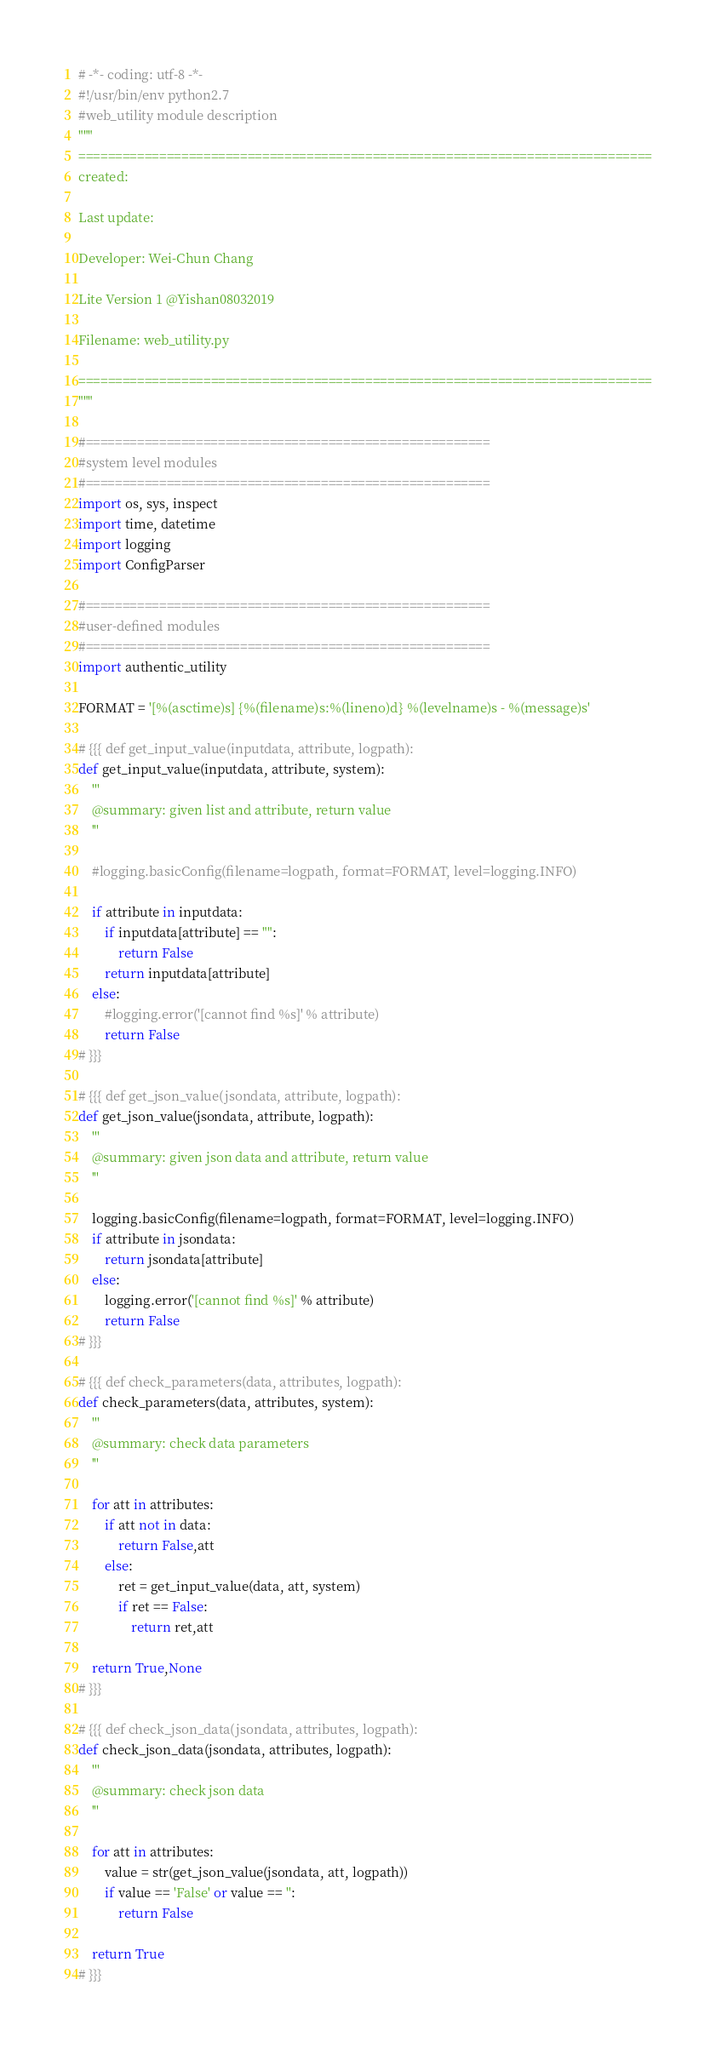<code> <loc_0><loc_0><loc_500><loc_500><_Python_># -*- coding: utf-8 -*-
#!/usr/bin/env python2.7
#web_utility module description
"""
==============================================================================
created: 

Last update: 
 
Developer: Wei-Chun Chang 
 
Lite Version 1 @Yishan08032019
 
Filename: web_utility.py
 
==============================================================================
"""

#=======================================================
#system level modules
#=======================================================
import os, sys, inspect
import time, datetime
import logging
import ConfigParser

#=======================================================
#user-defined modules
#=======================================================
import authentic_utility

FORMAT = '[%(asctime)s] {%(filename)s:%(lineno)d} %(levelname)s - %(message)s'

# {{{ def get_input_value(inputdata, attribute, logpath):
def get_input_value(inputdata, attribute, system):
    '''
    @summary: given list and attribute, return value
    '''

    #logging.basicConfig(filename=logpath, format=FORMAT, level=logging.INFO)

    if attribute in inputdata:
        if inputdata[attribute] == "":
            return False
        return inputdata[attribute]
    else:
        #logging.error('[cannot find %s]' % attribute)
        return False
# }}}

# {{{ def get_json_value(jsondata, attribute, logpath):
def get_json_value(jsondata, attribute, logpath):
    '''
    @summary: given json data and attribute, return value
    '''

    logging.basicConfig(filename=logpath, format=FORMAT, level=logging.INFO)
    if attribute in jsondata:
        return jsondata[attribute]
    else:
        logging.error('[cannot find %s]' % attribute)
        return False
# }}}

# {{{ def check_parameters(data, attributes, logpath):
def check_parameters(data, attributes, system):
    '''
    @summary: check data parameters
    '''

    for att in attributes:
        if att not in data:
            return False,att
        else:
            ret = get_input_value(data, att, system)
            if ret == False:
                return ret,att

    return True,None
# }}}

# {{{ def check_json_data(jsondata, attributes, logpath):
def check_json_data(jsondata, attributes, logpath):
    '''
    @summary: check json data
    '''

    for att in attributes:
        value = str(get_json_value(jsondata, att, logpath))
        if value == 'False' or value == '':
            return False

    return True
# }}}
</code> 